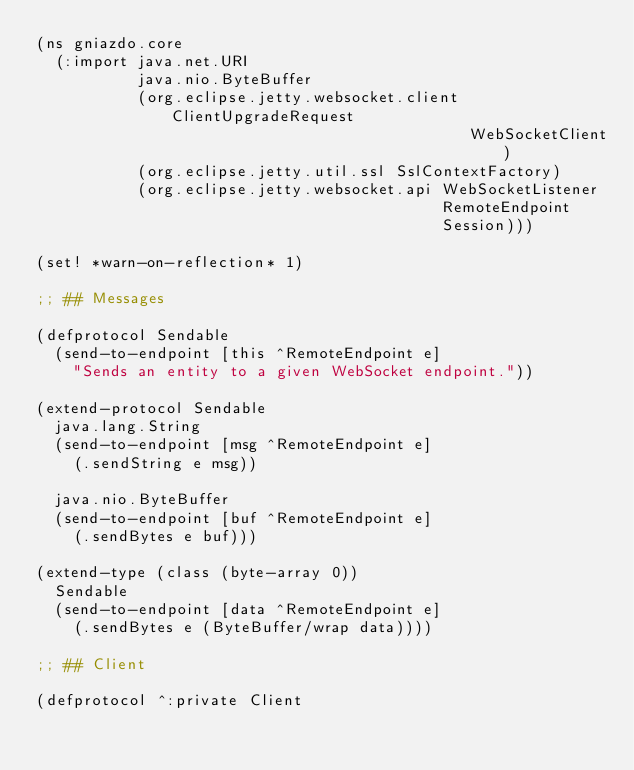<code> <loc_0><loc_0><loc_500><loc_500><_Clojure_>(ns gniazdo.core
  (:import java.net.URI
           java.nio.ByteBuffer
           (org.eclipse.jetty.websocket.client ClientUpgradeRequest
                                               WebSocketClient)
           (org.eclipse.jetty.util.ssl SslContextFactory)
           (org.eclipse.jetty.websocket.api WebSocketListener
                                            RemoteEndpoint
                                            Session)))

(set! *warn-on-reflection* 1)

;; ## Messages

(defprotocol Sendable
  (send-to-endpoint [this ^RemoteEndpoint e]
    "Sends an entity to a given WebSocket endpoint."))

(extend-protocol Sendable
  java.lang.String
  (send-to-endpoint [msg ^RemoteEndpoint e]
    (.sendString e msg))

  java.nio.ByteBuffer
  (send-to-endpoint [buf ^RemoteEndpoint e]
    (.sendBytes e buf)))

(extend-type (class (byte-array 0))
  Sendable
  (send-to-endpoint [data ^RemoteEndpoint e]
    (.sendBytes e (ByteBuffer/wrap data))))

;; ## Client

(defprotocol ^:private Client</code> 